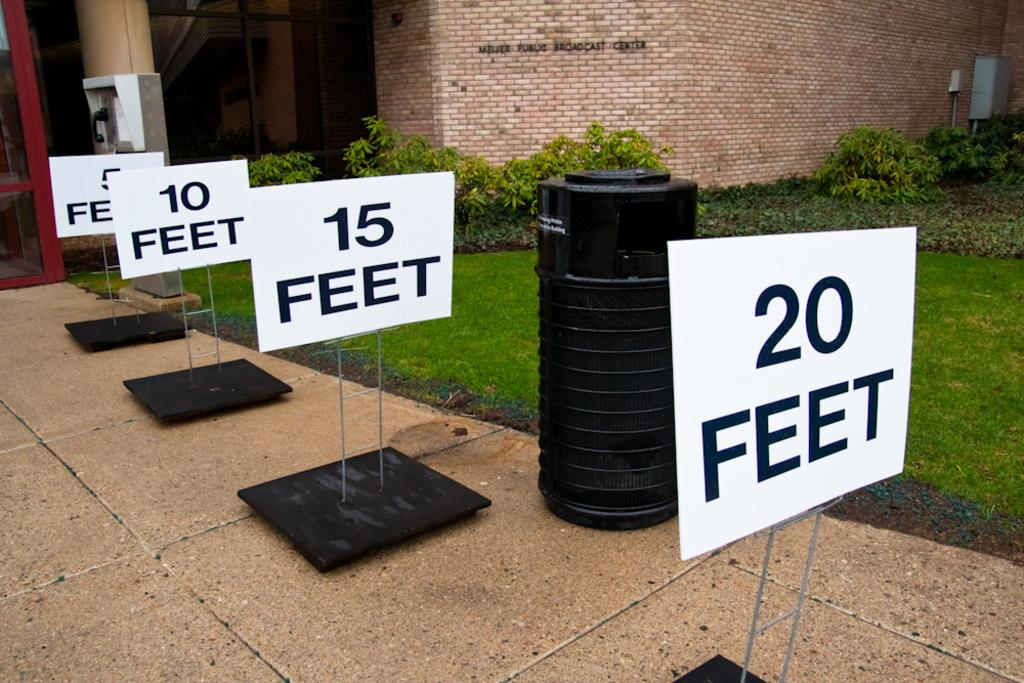<image>
Present a compact description of the photo's key features. Signs are placed on a sidewalk that say 20 Feet, 15 Feet, and 10 Feet. 